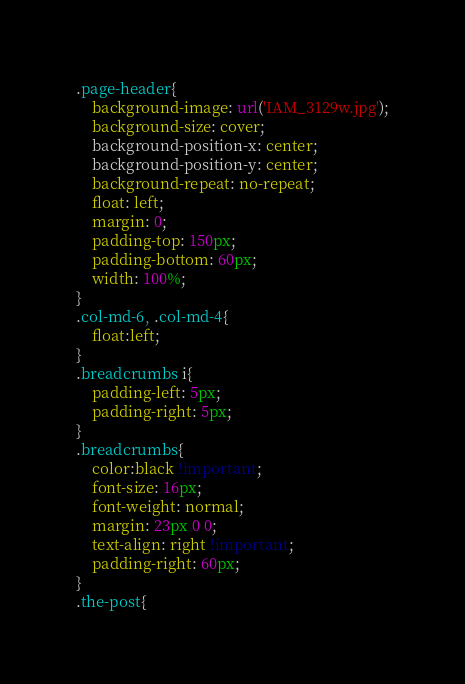Convert code to text. <code><loc_0><loc_0><loc_500><loc_500><_CSS_>.page-header{
    background-image: url('IAM_3129w.jpg');
    background-size: cover;
    background-position-x: center;
    background-position-y: center;
    background-repeat: no-repeat;
    float: left;
    margin: 0;
    padding-top: 150px;
    padding-bottom: 60px;
    width: 100%;
}
.col-md-6, .col-md-4{
    float:left;
}
.breadcrumbs i{
    padding-left: 5px;
    padding-right: 5px;
}
.breadcrumbs{
    color:black !important;
    font-size: 16px;
    font-weight: normal;
    margin: 23px 0 0;
    text-align: right !important;
    padding-right: 60px;
}
.the-post{</code> 